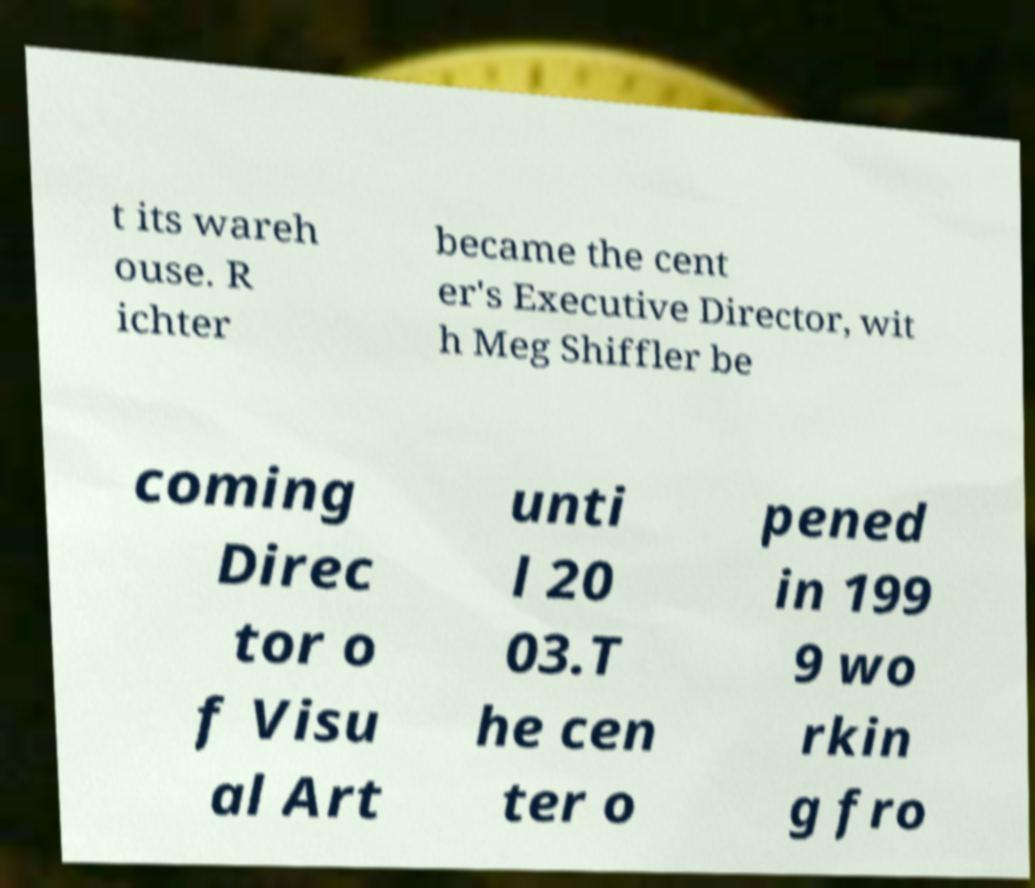There's text embedded in this image that I need extracted. Can you transcribe it verbatim? t its wareh ouse. R ichter became the cent er's Executive Director, wit h Meg Shiffler be coming Direc tor o f Visu al Art unti l 20 03.T he cen ter o pened in 199 9 wo rkin g fro 